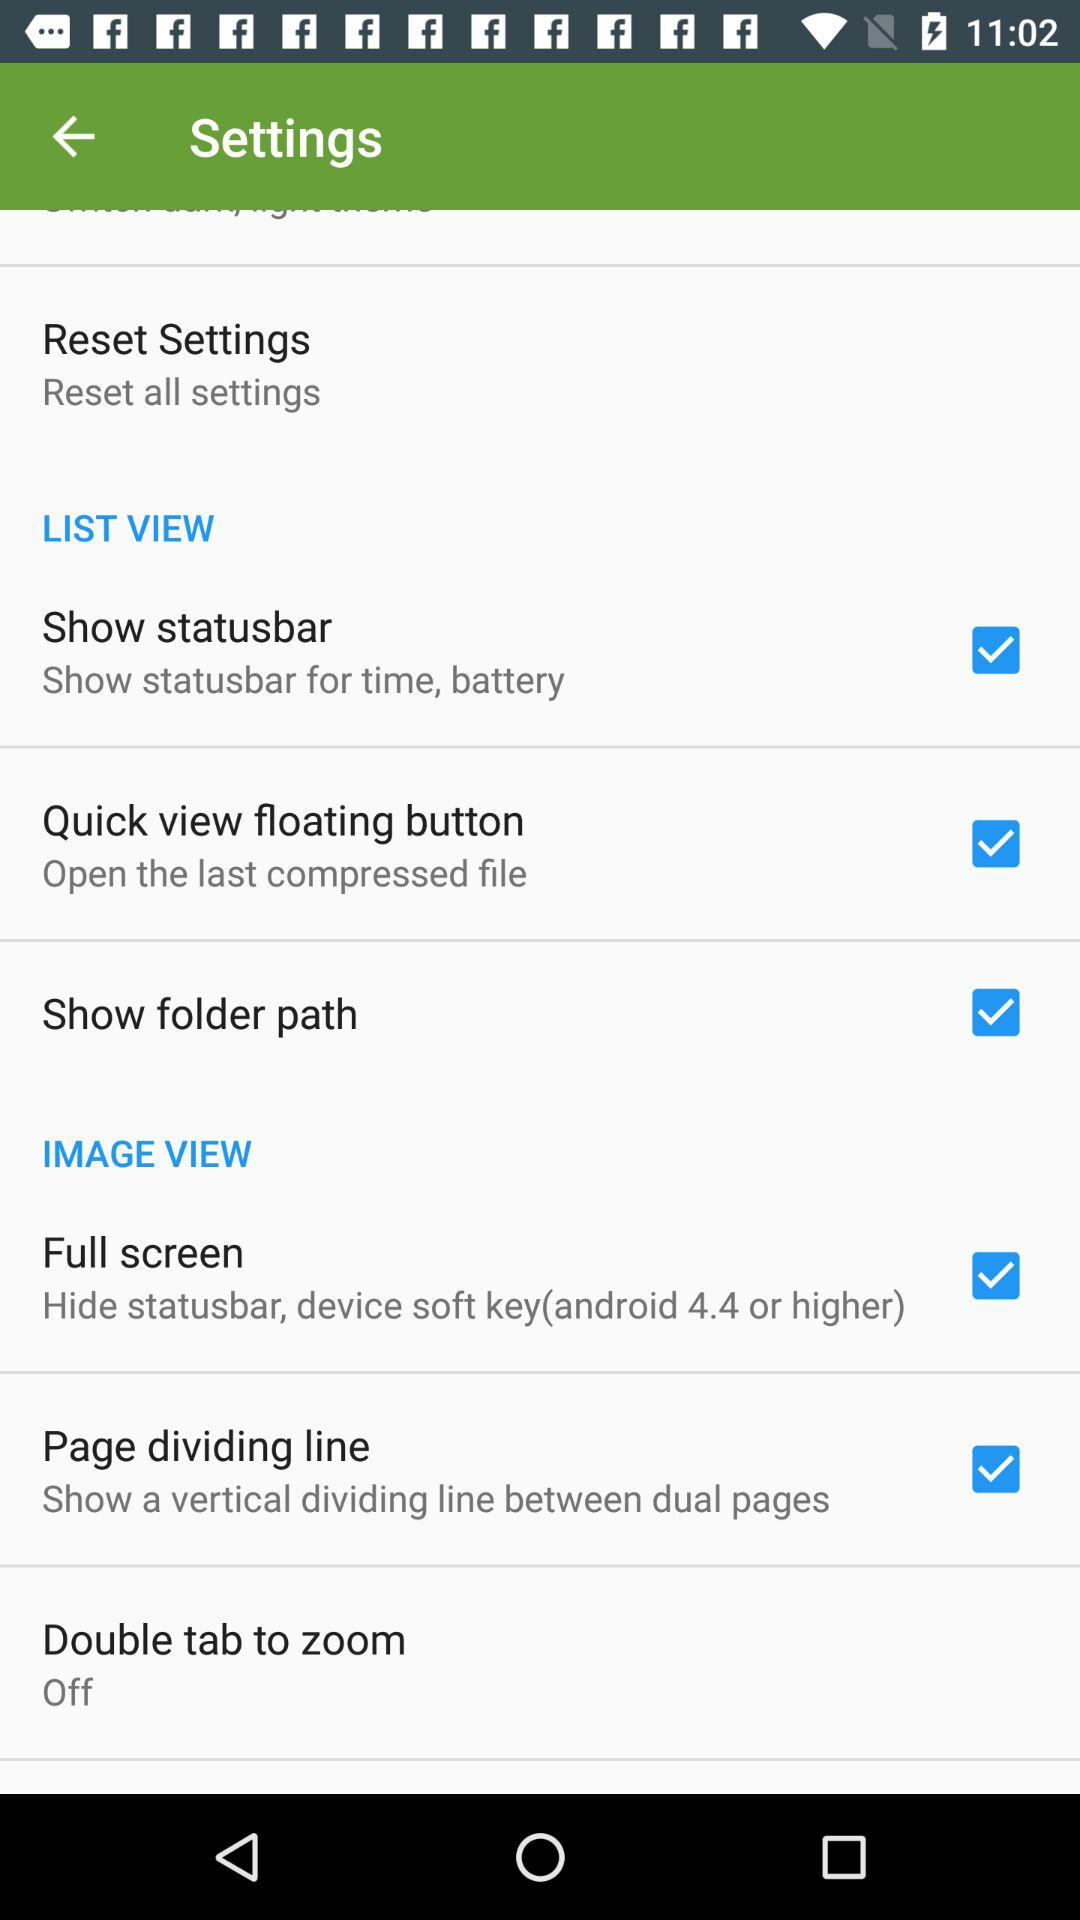What is the status of the "Page dividing line" settings? The status is on. 